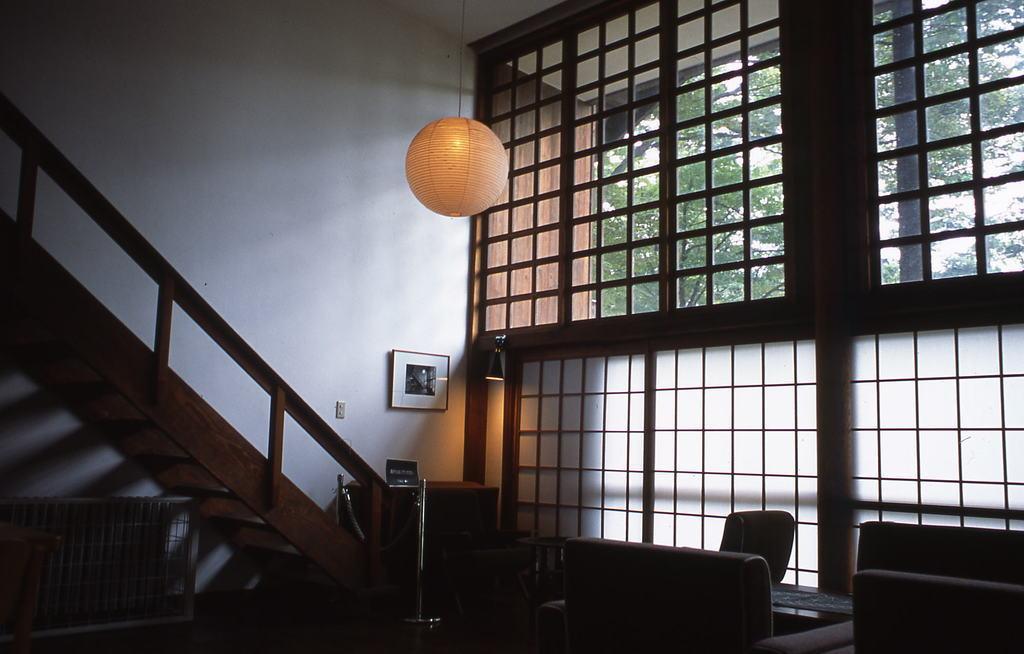Can you describe this image briefly? In this image we can see tables, chairs, cupboard, stairs, railing and one object. We can see a frame is attached to the wall. Right side of the image, we can see windows. Behind the windows, we can see trees. There is a light hang from the roof at the top of the image. 